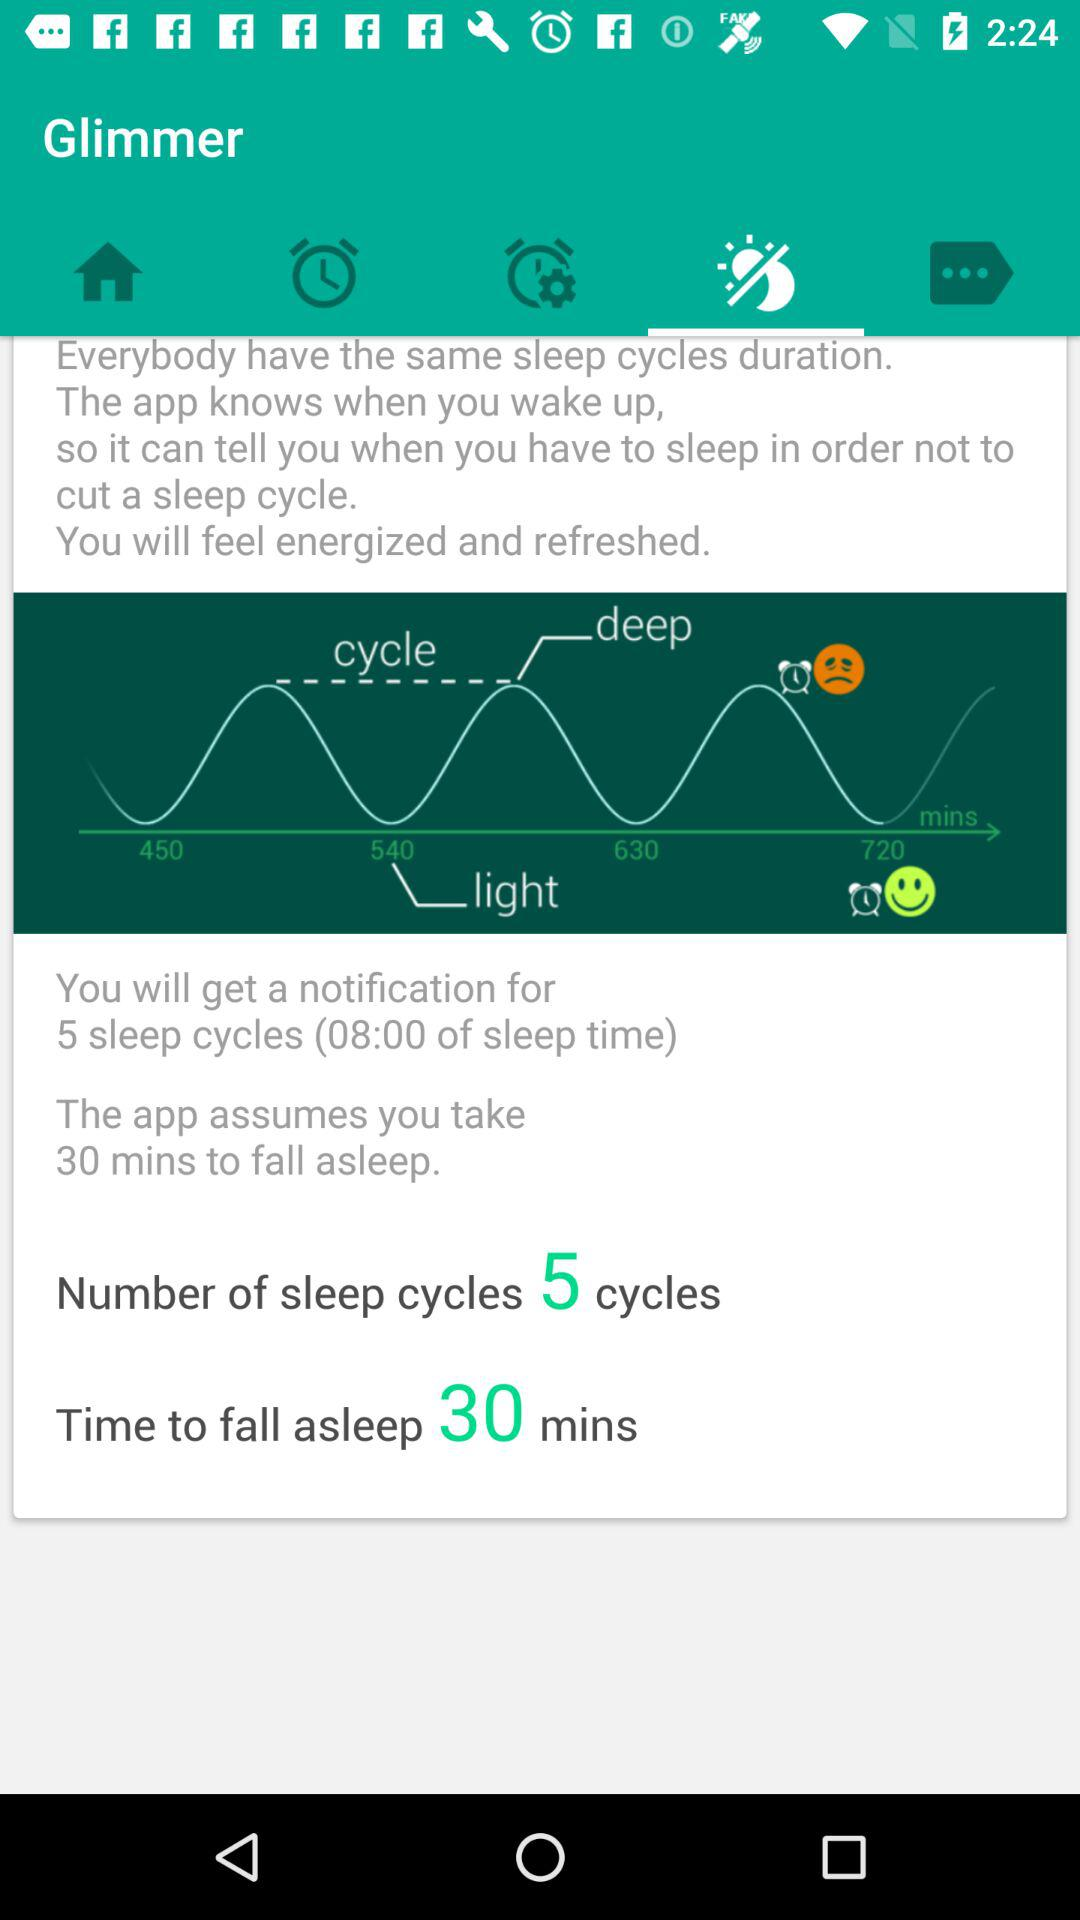What is the duration mentioned for "Time to fall asleep"? The mentioned duration is 30 minutes. 